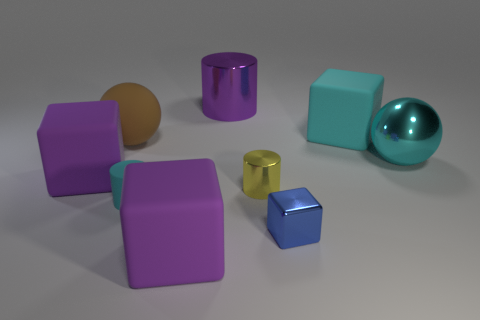How many other things are there of the same shape as the large cyan matte object?
Give a very brief answer. 3. Is the number of tiny blue objects that are on the right side of the cyan metal thing greater than the number of large cyan cubes?
Your answer should be compact. No. Is there any other thing that is the same color as the big metallic sphere?
Offer a very short reply. Yes. There is a tiny yellow object that is made of the same material as the large purple cylinder; what shape is it?
Give a very brief answer. Cylinder. Does the tiny cylinder in front of the yellow shiny thing have the same material as the cyan block?
Give a very brief answer. Yes. What shape is the large thing that is the same color as the metallic ball?
Provide a succinct answer. Cube. Is the color of the large block that is on the right side of the tiny cube the same as the big sphere on the right side of the small cyan cylinder?
Keep it short and to the point. Yes. What number of rubber cubes are both behind the small cyan matte thing and in front of the rubber ball?
Make the answer very short. 1. What is the material of the small yellow thing?
Offer a very short reply. Metal. There is a yellow metal object that is the same size as the cyan cylinder; what shape is it?
Give a very brief answer. Cylinder. 